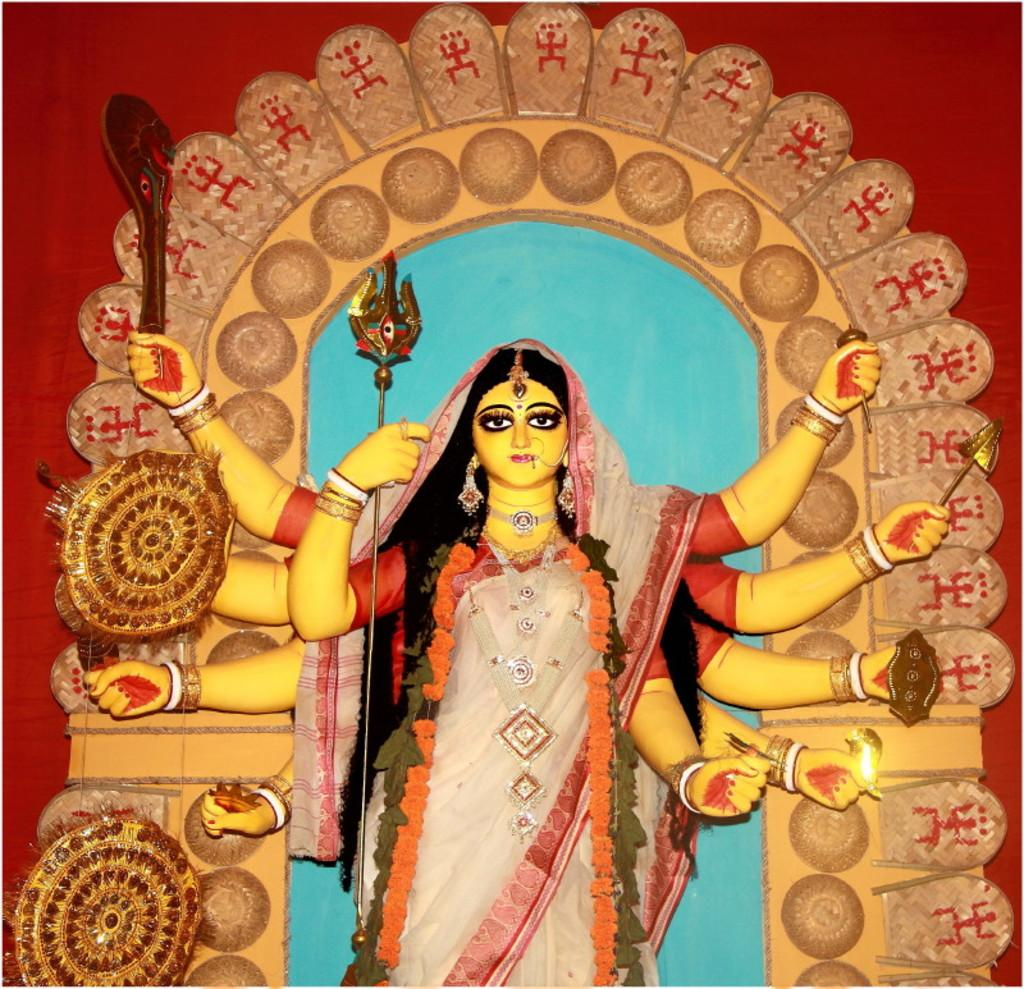What is the main subject of the image? There is a statue in the image. What is the statue wearing? The statue is wearing a saree. What colors are present in the saree? The saree has cream and red colors. How would you describe the background wall in the image? The background wall has red, brown, and blue colors. Is there a crate filled with zinc in the image? No, there is no crate or zinc present in the image. 